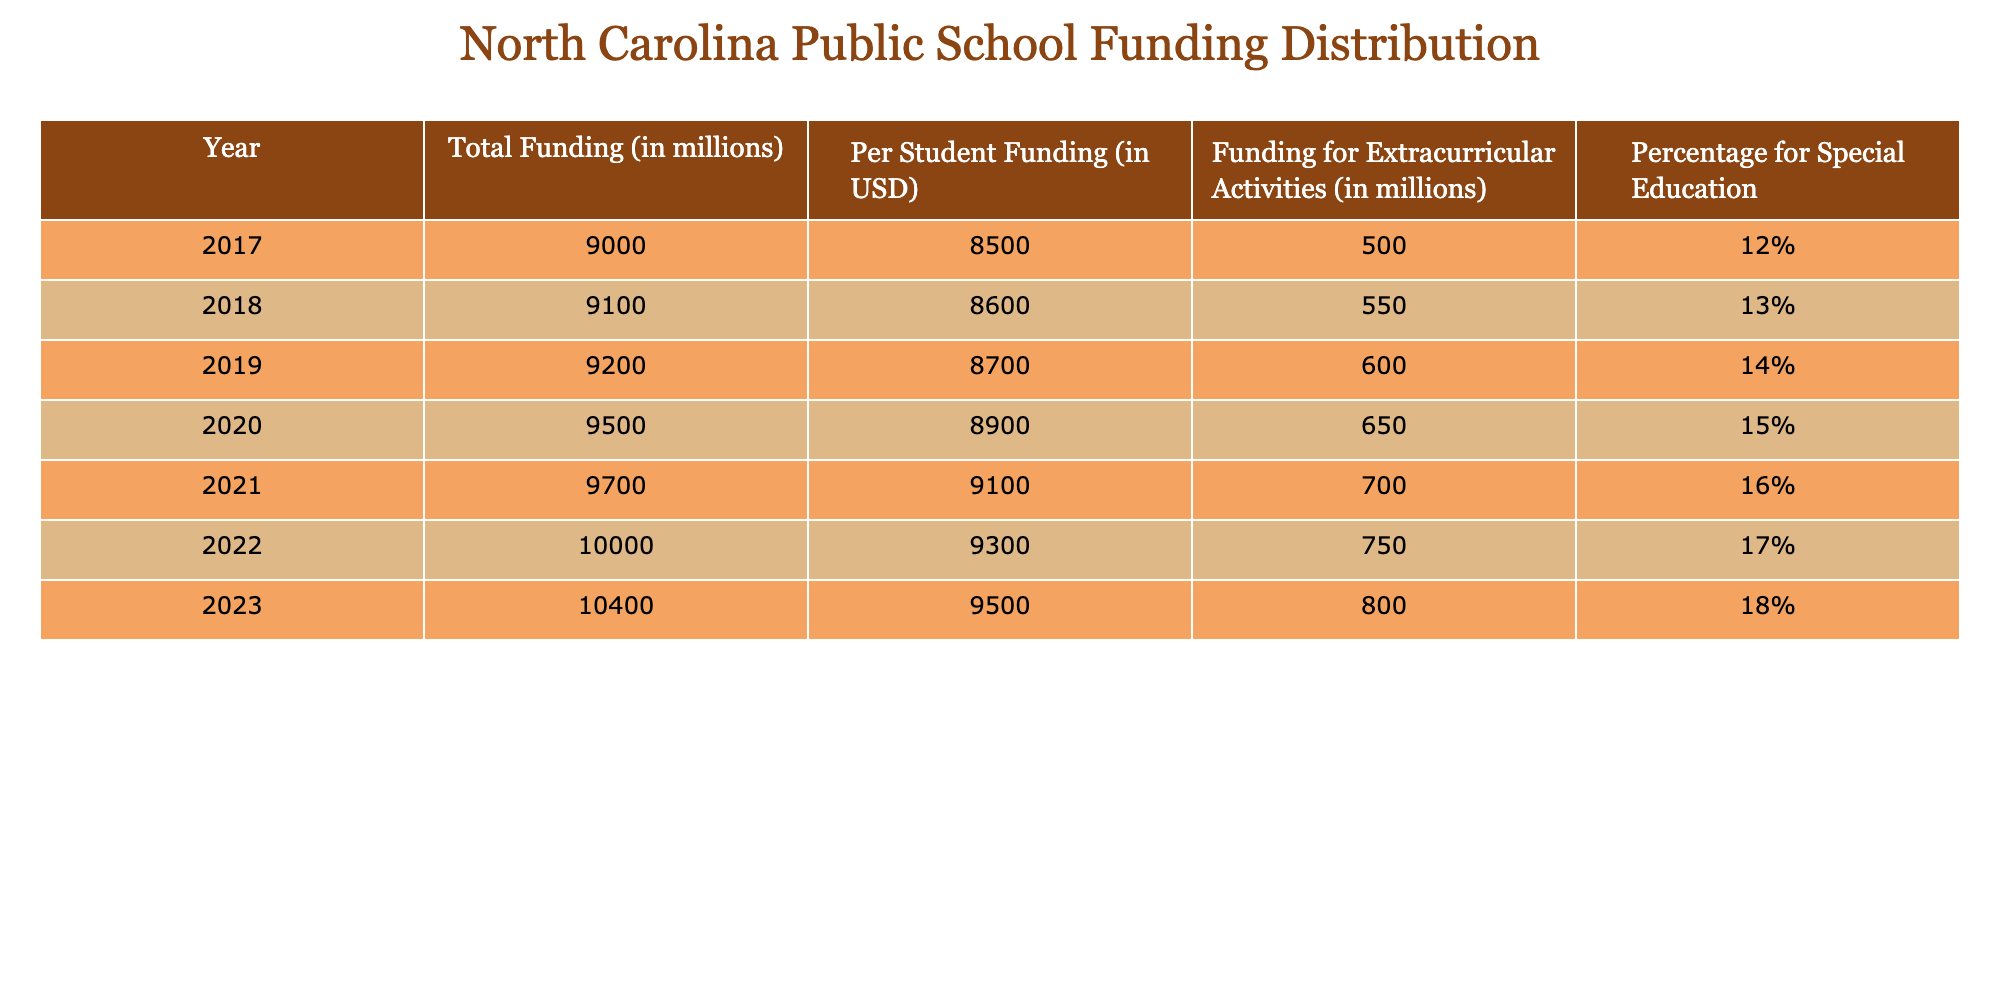What was the total funding for North Carolina public schools in 2022? The table displays that the total funding in 2022 is listed directly in the corresponding row under the "Total Funding (in millions)" column. The value is 10,000 million.
Answer: 10,000 million What percentage of the total funding in 2023 was allocated to special education? According to the table, the "Percentage for Special Education" column for 2023 shows a value of 18%. This percentage indicates the portion of the total funding dedicated to special education for that year.
Answer: 18% How much did North Carolina public schools spend on extracurricular activities in 2019 compared to 2021? The table shows the amounts spent on extracurricular activities in 2019 and 2021 under the "Funding for Extracurricular Activities (in millions)" column, which are 600 million for 2019 and 700 million for 2021. To find the difference, we subtract 600 from 700, resulting in an increase of 100 million.
Answer: The difference is 100 million What is the average per-student funding from 2017 to 2023? To find the average per-student funding, we first sum the values from the "Per Student Funding (in USD)" column for the years 2017 through 2023. The sum is (8500 + 8600 + 8700 + 8900 + 9100 + 9300 + 9500) = 62,600. Since there are 7 years, we divide this sum by 7 to get the average: 62,600 / 7 ≈ 8,943.
Answer: Approximately 8,943 Was there an increase in funding for extracurricular activities from 2018 to 2020? By checking the "Funding for Extracurricular Activities (in millions)" column, we find that the funding was 550 million in 2018 and 650 million in 2020. Since 650 is greater than 550, this indicates an increase.
Answer: Yes, there was an increase What year had the highest total funding for North Carolina public schools? The highest total funding can be determined by looking across the "Total Funding (in millions)" column to identify the largest value. The value for 2023 stands at 10,400 million, which is greater than all previous years.
Answer: 2023 had the highest total funding In how many years did the funding for special education increase compared to the previous year? By examining the "Percentage for Special Education" column, we see that the values increased from 12% in 2017 to 18% in 2023. The increases occur in 2018 (13%), 2019 (14%), 2020 (15%), 2021 (16%), and 2022 (17%). Counting these increases gives us 5 years of increase.
Answer: 5 years 